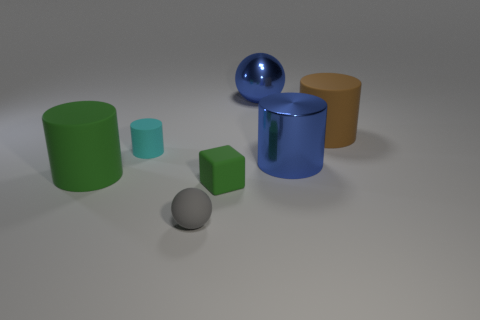Subtract 1 cylinders. How many cylinders are left? 3 Add 2 big brown cylinders. How many objects exist? 9 Subtract all cubes. How many objects are left? 6 Subtract all blue cubes. Subtract all tiny objects. How many objects are left? 4 Add 7 green cubes. How many green cubes are left? 8 Add 4 large matte cylinders. How many large matte cylinders exist? 6 Subtract 0 yellow spheres. How many objects are left? 7 